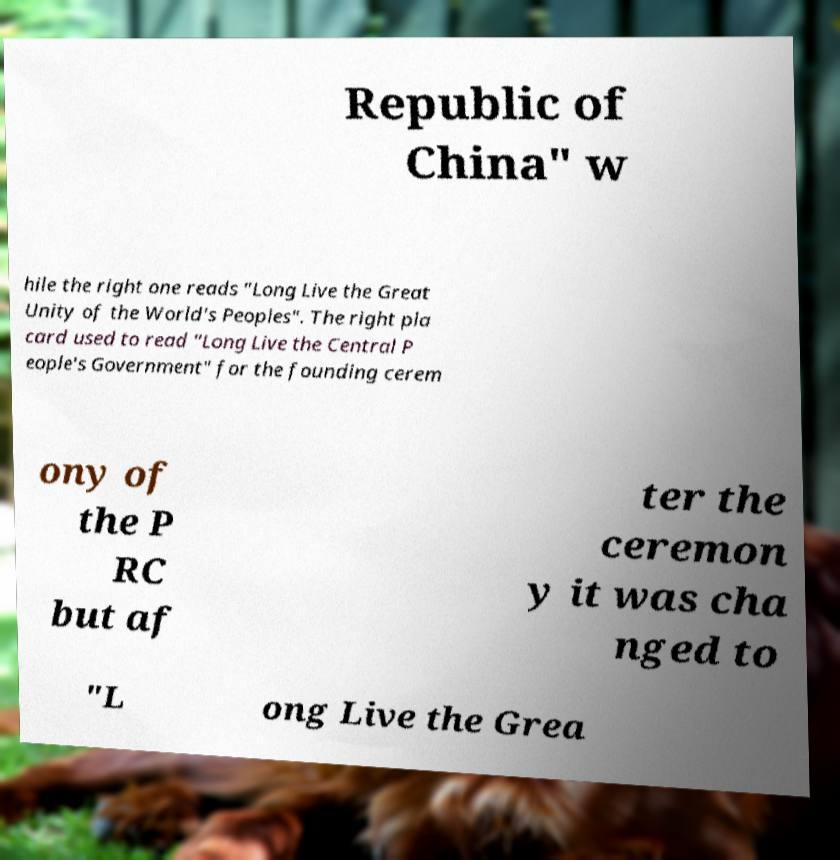I need the written content from this picture converted into text. Can you do that? Republic of China" w hile the right one reads "Long Live the Great Unity of the World's Peoples". The right pla card used to read "Long Live the Central P eople's Government" for the founding cerem ony of the P RC but af ter the ceremon y it was cha nged to "L ong Live the Grea 